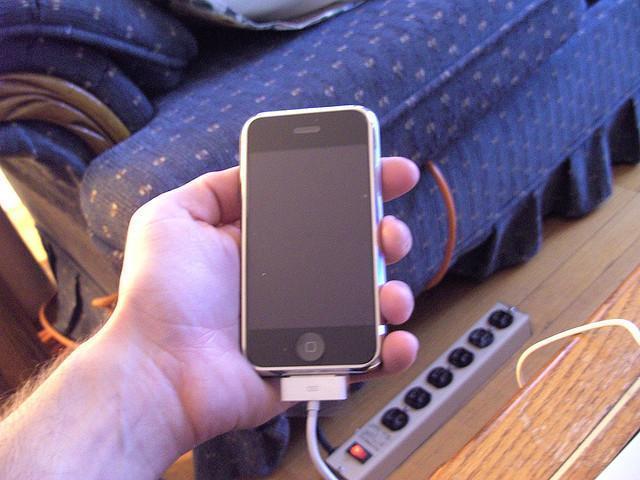How many umbrellas have more than 4 colors?
Give a very brief answer. 0. 